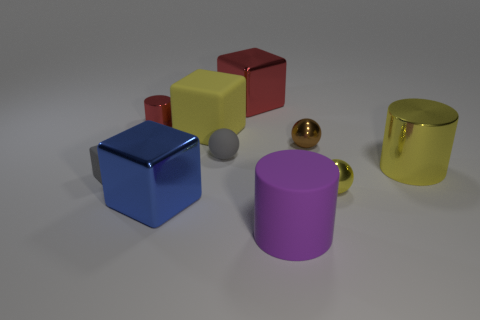What number of tiny yellow balls are the same material as the big purple object?
Your answer should be very brief. 0. How many things are tiny yellow shiny spheres or metallic things that are right of the big yellow matte object?
Your answer should be very brief. 4. Are the big yellow thing that is to the right of the gray matte sphere and the yellow sphere made of the same material?
Provide a succinct answer. Yes. What color is the metallic cylinder that is the same size as the gray block?
Ensure brevity in your answer.  Red. Is there a large red object that has the same shape as the blue metal thing?
Your answer should be compact. Yes. What is the color of the metal cylinder on the left side of the large metallic cube that is to the left of the big metallic block behind the blue shiny thing?
Ensure brevity in your answer.  Red. What number of matte objects are either small gray things or blue blocks?
Keep it short and to the point. 2. Are there more big blue metallic objects on the right side of the tiny red cylinder than tiny gray blocks behind the tiny rubber cube?
Your response must be concise. Yes. How many other things are there of the same size as the purple matte cylinder?
Ensure brevity in your answer.  4. What size is the rubber cube that is behind the small matte thing that is in front of the yellow metallic cylinder?
Give a very brief answer. Large. 